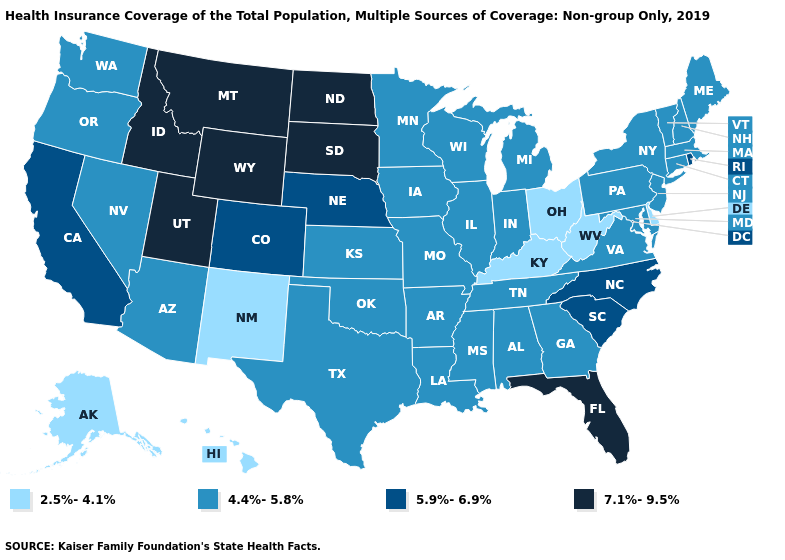Name the states that have a value in the range 5.9%-6.9%?
Keep it brief. California, Colorado, Nebraska, North Carolina, Rhode Island, South Carolina. Which states have the lowest value in the South?
Give a very brief answer. Delaware, Kentucky, West Virginia. What is the value of New York?
Keep it brief. 4.4%-5.8%. How many symbols are there in the legend?
Write a very short answer. 4. What is the value of California?
Keep it brief. 5.9%-6.9%. What is the value of Maine?
Short answer required. 4.4%-5.8%. Is the legend a continuous bar?
Write a very short answer. No. Which states have the lowest value in the USA?
Be succinct. Alaska, Delaware, Hawaii, Kentucky, New Mexico, Ohio, West Virginia. How many symbols are there in the legend?
Write a very short answer. 4. Does Nevada have a higher value than West Virginia?
Quick response, please. Yes. Does Alabama have the same value as Pennsylvania?
Concise answer only. Yes. Does Rhode Island have the lowest value in the Northeast?
Keep it brief. No. Name the states that have a value in the range 2.5%-4.1%?
Short answer required. Alaska, Delaware, Hawaii, Kentucky, New Mexico, Ohio, West Virginia. Among the states that border Alabama , which have the lowest value?
Short answer required. Georgia, Mississippi, Tennessee. 